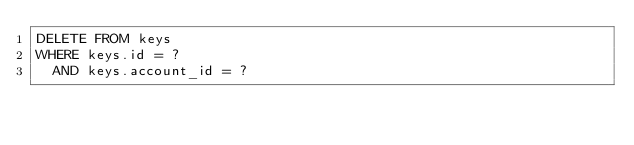Convert code to text. <code><loc_0><loc_0><loc_500><loc_500><_SQL_>DELETE FROM keys
WHERE keys.id = ?
  AND keys.account_id = ?
</code> 